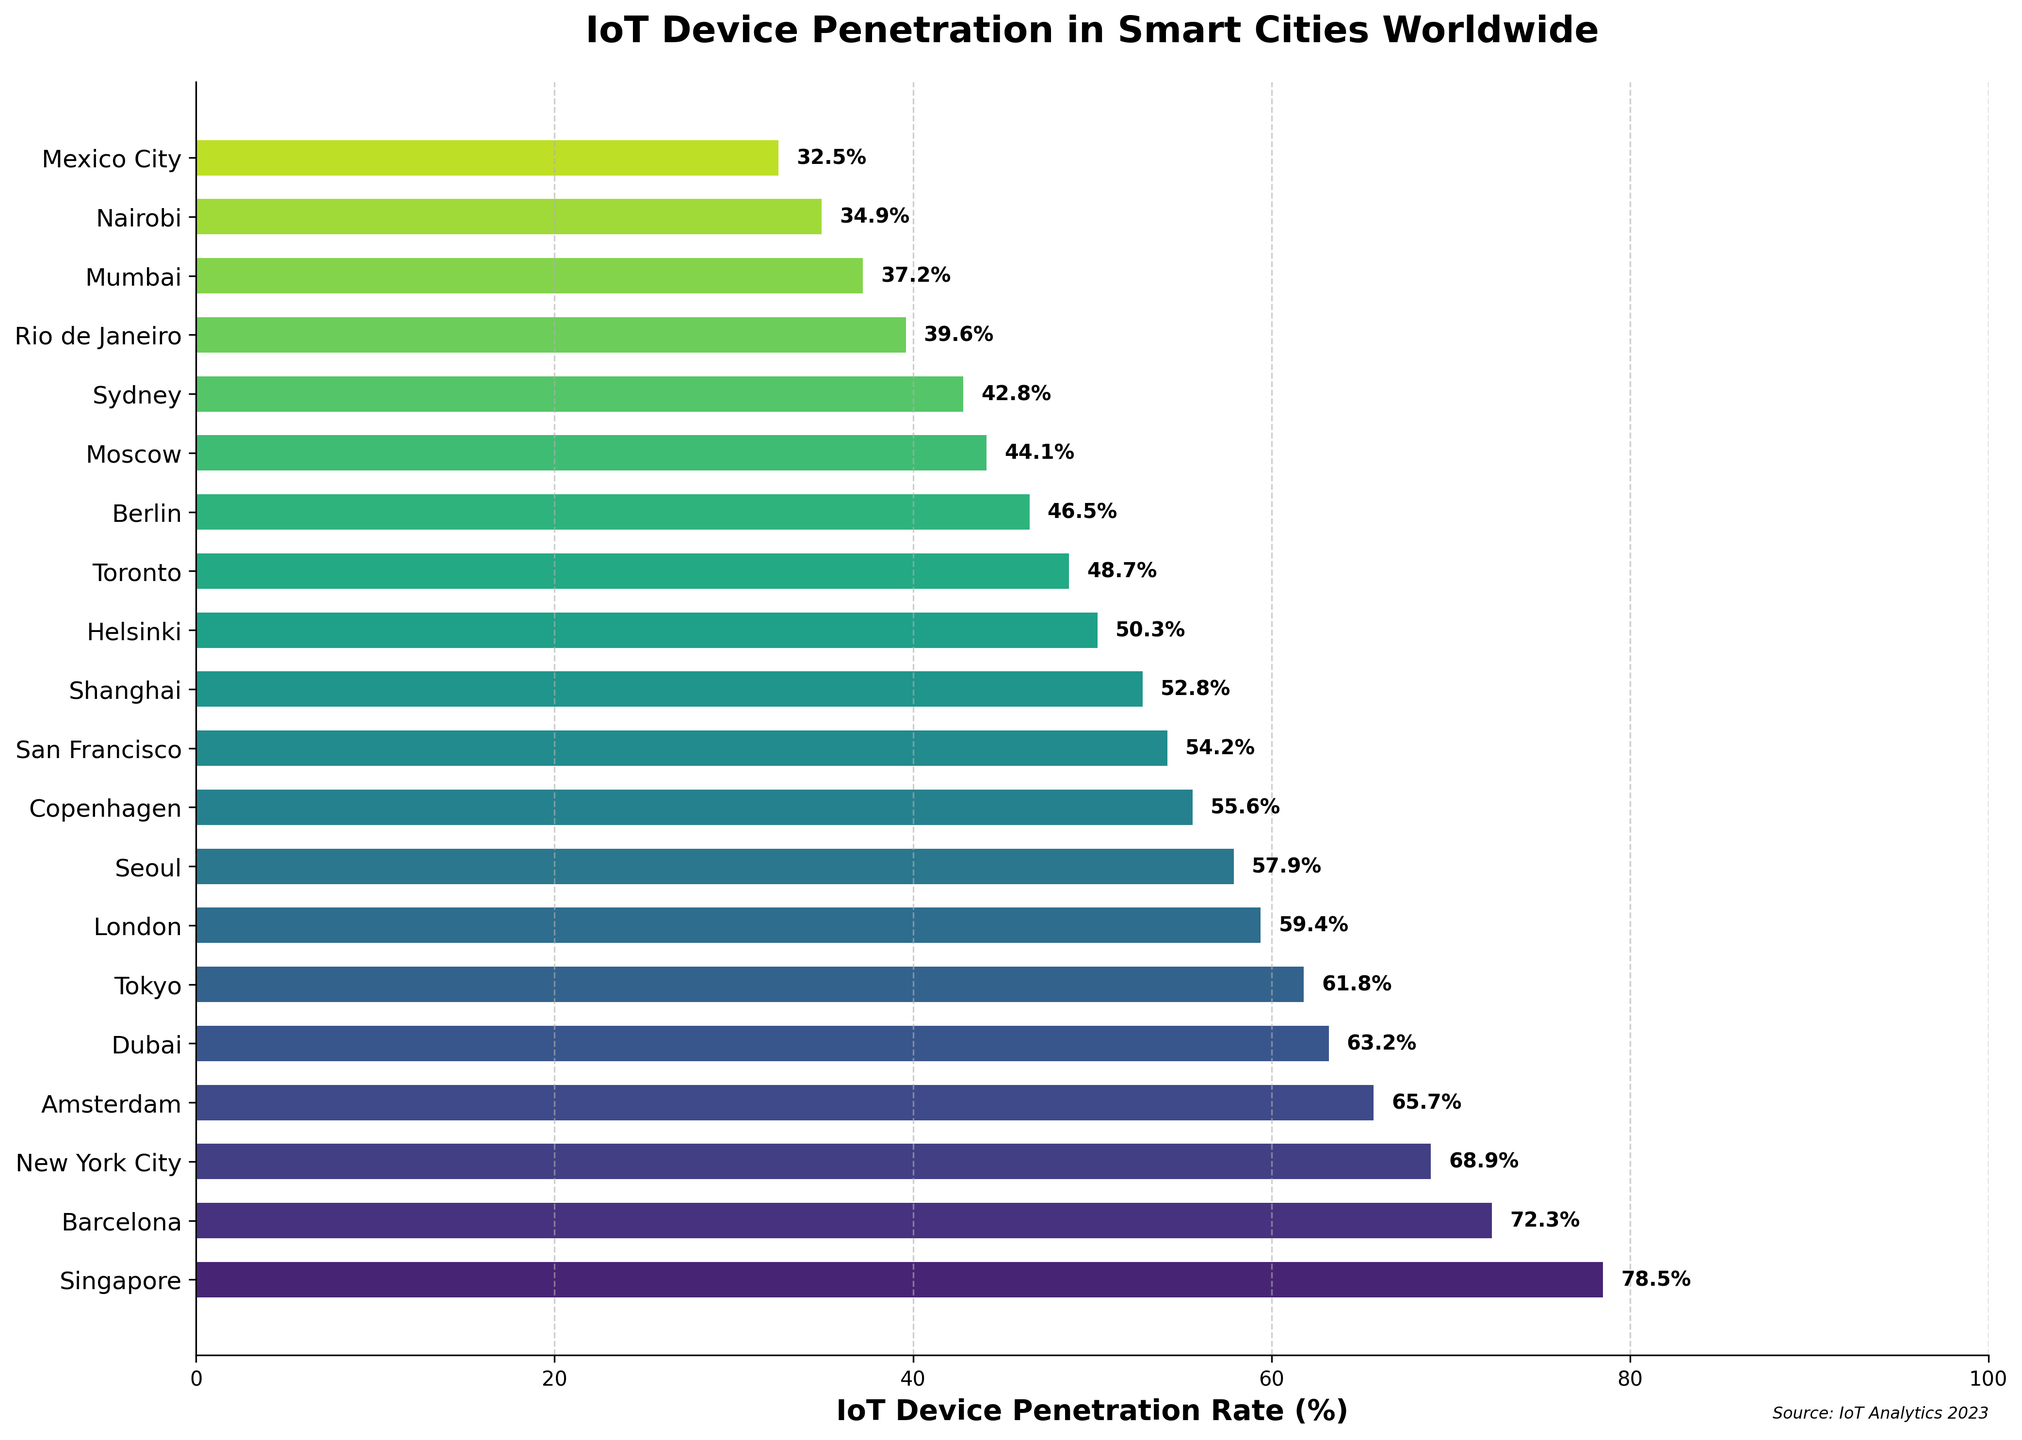Which city has the highest IoT device penetration rate? The highest bar represents the city with the highest IoT device penetration rate. Singapore has the highest penetration rate of 78.5%.
Answer: Singapore What is the difference in IoT device penetration rates between New York City and Tokyo? New York City's penetration rate is 68.9%, and Tokyo's is 61.8%. The difference is 68.9 - 61.8 = 7.1%.
Answer: 7.1% Which cities have a penetration rate above 60%? To find this, look for bars that extend beyond the 60% mark. The cities are Singapore, Barcelona, New York City, Amsterdam, Dubai, and Tokyo.
Answer: Singapore, Barcelona, New York City, Amsterdam, Dubai, Tokyo How much higher is the penetration rate in Singapore compared to Mexico City? Singapore has a rate of 78.5%, and Mexico City has 32.5%. The difference is 78.5 - 32.5 = 46%.
Answer: 46% What is the average IoT device penetration rate among the top 5 cities? The top 5 cities are Singapore (78.5%), Barcelona (72.3%), New York City (68.9%), Amsterdam (65.7%), and Dubai (63.2%). The average is (78.5 + 72.3 + 68.9 + 65.7 + 63.2) / 5 = 69.72%.
Answer: 69.72% Which city has the lowest IoT device penetration rate, and what is it? The shortest bar represents the city with the lowest penetration rate. Mexico City has the lowest rate at 32.5%.
Answer: Mexico City, 32.5% Are the IoT device penetration rates of London and Seoul more than 55%? London has a penetration rate of 59.4% and Seoul 57.9%. Both rates are indeed more than 55%.
Answer: Yes What is the median IoT device penetration rate of the listed cities? When the penetration rates are sorted, the median is the middle value. There are 20 cities, so the median is the average of the 10th and 11th values. Sorted rates: 78.5, 72.3, 68.9, 65.7, 63.2, 61.8, 59.4, 57.9, 55.6, 54.2, 52.8. Average of 10th (54.2) and 11th (52.8) is (54.2 + 52.8) / 2 = 53.5%.
Answer: 53.5% Which city shows a slightly lower penetration rate than Amsterdam but higher than Dubai? Amsterdam's rate is 65.7%, and Dubai's is 63.2%. New York City fits as it has a rate of 68.9%, higher than both.
Answer: New York City Are there more cities with a penetration rate above or below 50%? Count the cities with rates above and below 50%. Above 50%: 12 cities. Below 50%: 8 cities. There are more cities with a rate above 50%.
Answer: Above 50% 